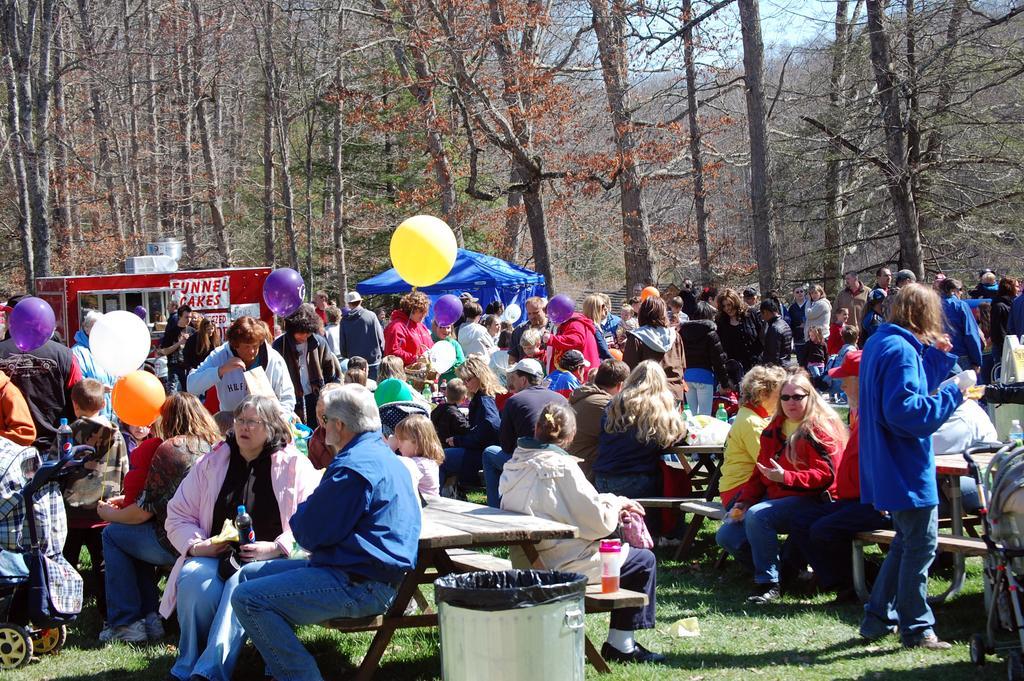In one or two sentences, can you explain what this image depicts? In this image there are stalls, in front of the stalls there are so many people standing, some are walking and sitting on the wooden bench in front of them there is a table with some objects on it and few are holding balloons, there is a dustbin on the surface of the grass. In the background there are trees. 